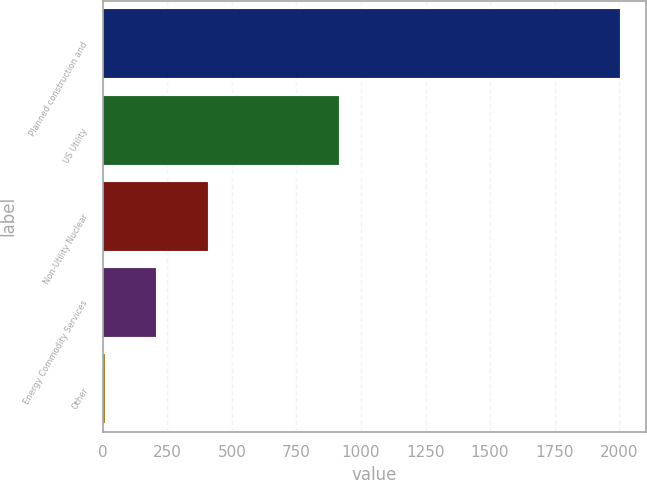Convert chart. <chart><loc_0><loc_0><loc_500><loc_500><bar_chart><fcel>Planned construction and<fcel>US Utility<fcel>Non-Utility Nuclear<fcel>Energy Commodity Services<fcel>Other<nl><fcel>2004<fcel>915<fcel>406.4<fcel>206.7<fcel>7<nl></chart> 